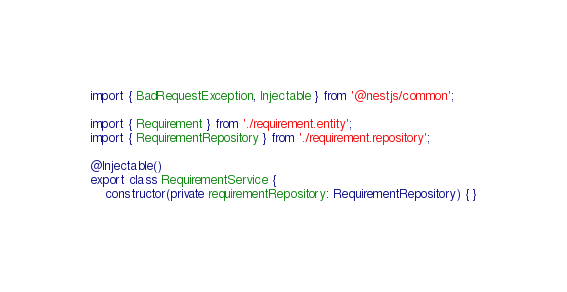<code> <loc_0><loc_0><loc_500><loc_500><_TypeScript_>import { BadRequestException, Injectable } from '@nestjs/common';

import { Requirement } from './requirement.entity';
import { RequirementRepository } from './requirement.repository';

@Injectable()
export class RequirementService {
    constructor(private requirementRepository: RequirementRepository) { }
</code> 